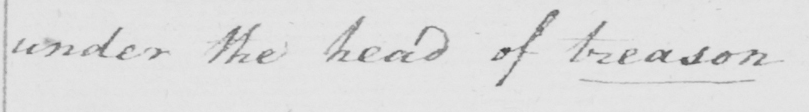Please transcribe the handwritten text in this image. under the head of treason 